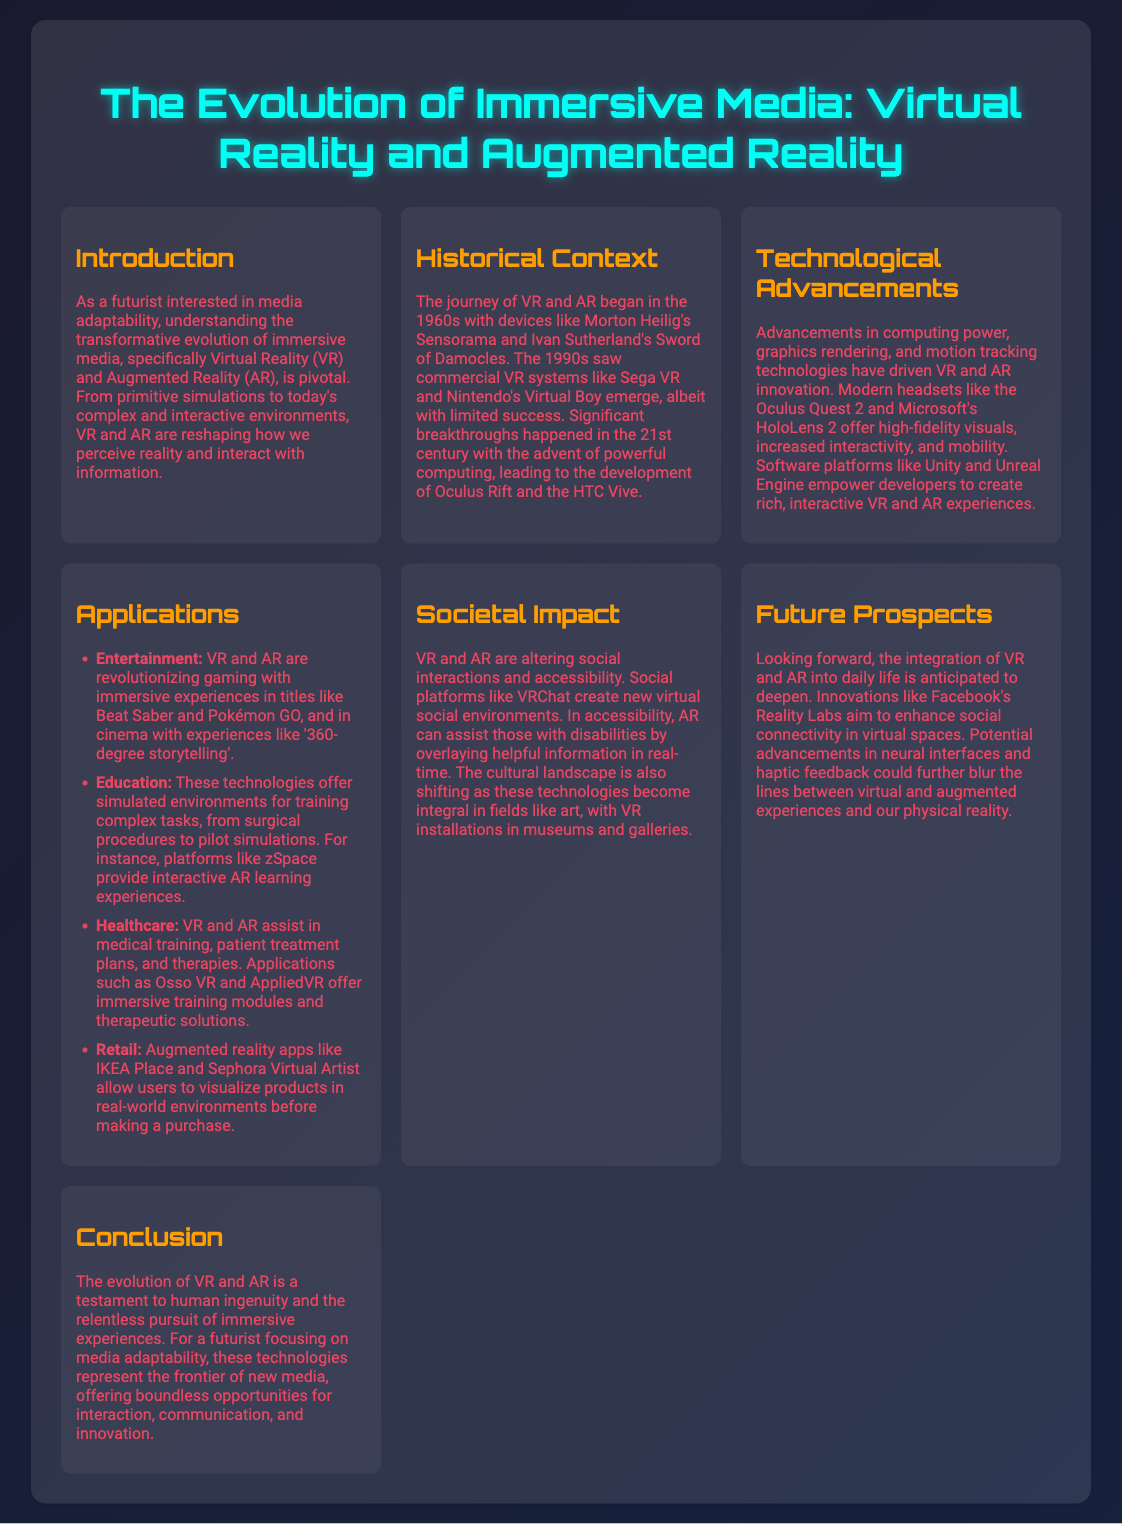What decade did the journey of VR and AR begin? The document states that the journey began in the 1960s.
Answer: 1960s Which devices were mentioned as early examples of VR technology? The early examples mentioned are Morton Heilig's Sensorama and Ivan Sutherland's Sword of Damocles.
Answer: Sensorama and Sword of Damocles What is a modern headset that offers high-fidelity visuals? The document lists Oculus Quest 2 as a modern headset offering high-fidelity visuals.
Answer: Oculus Quest 2 Which platform provides interactive AR learning experiences? The document mentions zSpace as a platform providing interactive AR learning experiences.
Answer: zSpace What societal aspect does VRChat influence? According to the document, VRChat creates new virtual social environments.
Answer: Social interactions What future innovation is mentioned aimed at enhancing social connectivity? Facebook's Reality Labs is mentioned as an innovation aiming to enhance social connectivity in virtual spaces.
Answer: Facebook's Reality Labs How are VR and AR transforming healthcare? The document states that VR and AR assist in medical training and patient treatment plans.
Answer: Medical training and patient treatment plans What type of media does the conclusion refer to regarding new opportunities? The conclusion discusses immersive experiences as the frontier of new media.
Answer: New media 